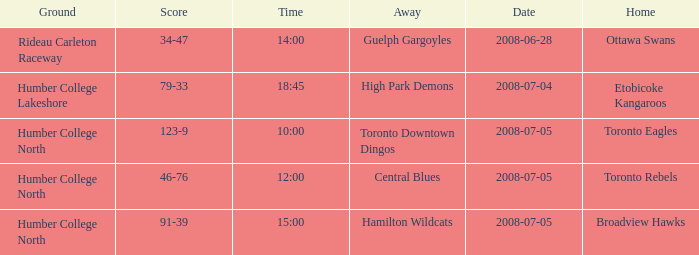What is the Date with a Time that is 18:45? 2008-07-04. Would you be able to parse every entry in this table? {'header': ['Ground', 'Score', 'Time', 'Away', 'Date', 'Home'], 'rows': [['Rideau Carleton Raceway', '34-47', '14:00', 'Guelph Gargoyles', '2008-06-28', 'Ottawa Swans'], ['Humber College Lakeshore', '79-33', '18:45', 'High Park Demons', '2008-07-04', 'Etobicoke Kangaroos'], ['Humber College North', '123-9', '10:00', 'Toronto Downtown Dingos', '2008-07-05', 'Toronto Eagles'], ['Humber College North', '46-76', '12:00', 'Central Blues', '2008-07-05', 'Toronto Rebels'], ['Humber College North', '91-39', '15:00', 'Hamilton Wildcats', '2008-07-05', 'Broadview Hawks']]} 